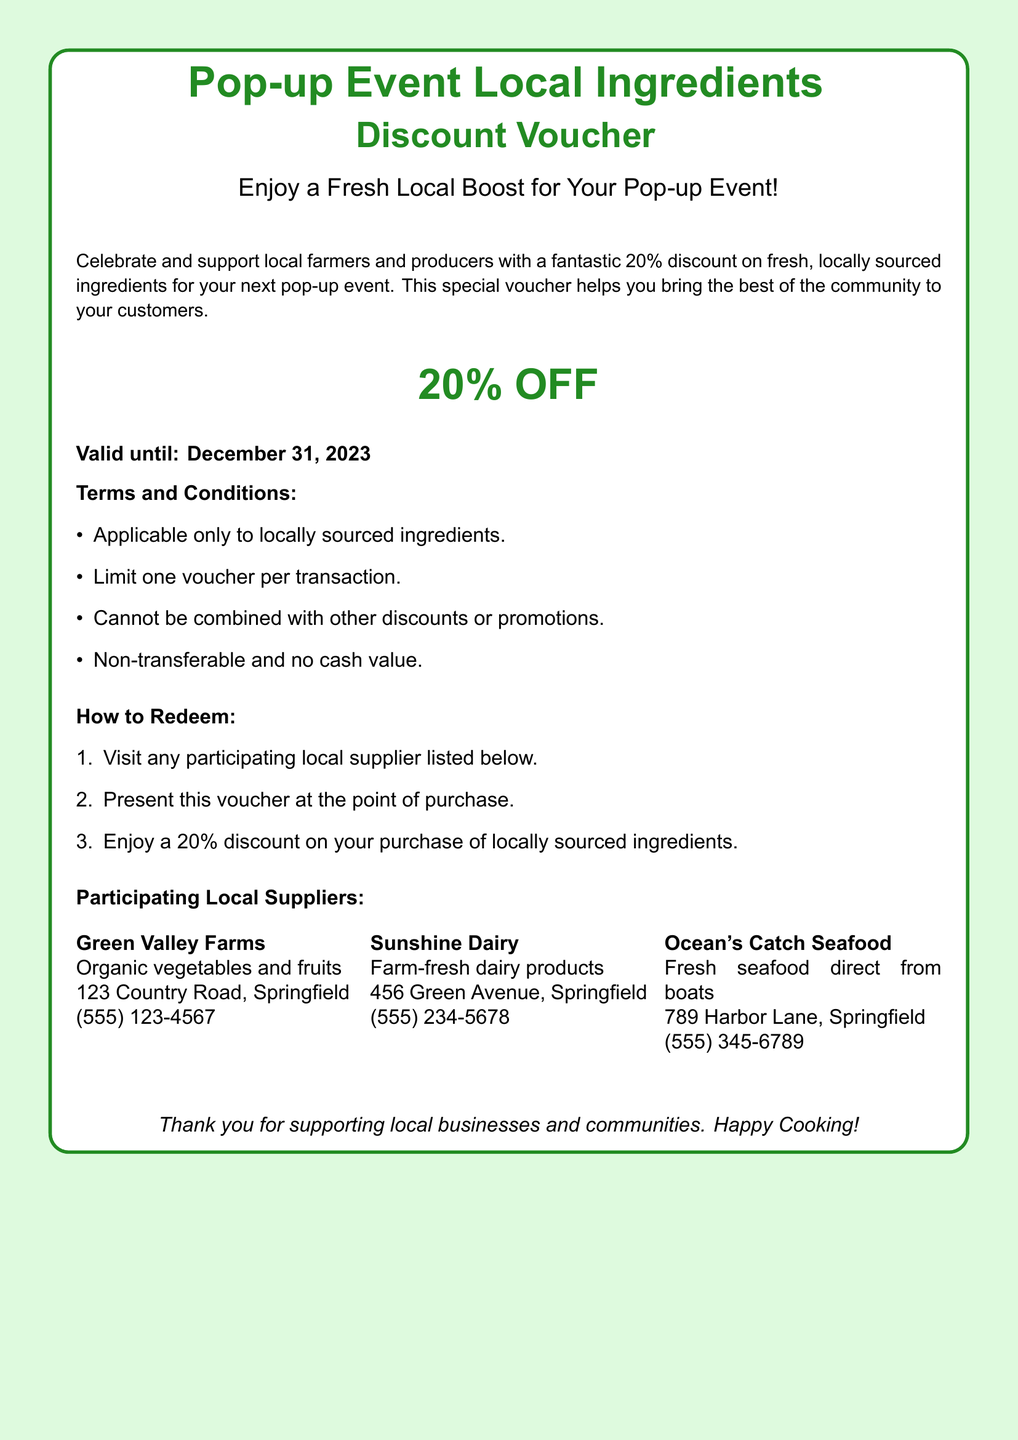What is the discount offered? The document states that the voucher provides a discount on fresh, locally sourced ingredients, specifically mentioning a 20% discount.
Answer: 20% What is the validity period of the voucher? The document specifies that the voucher is valid until December 31, 2023, indicating the time frame during which it can be used.
Answer: December 31, 2023 Which local supplier offers organic vegetables? The document lists Green Valley Farms as a local supplier that provides organic vegetables and fruits, answering the query about the type of food they sell.
Answer: Green Valley Farms How many suppliers are listed in the document? Counting the participating local suppliers presented in the document shows that there are three suppliers mentioned.
Answer: 3 What is the condition related to combining discounts? The document states that the voucher cannot be combined with other discounts or promotions, addressing limitations on usage.
Answer: Cannot be combined What is required to redeem the voucher? The redeeming process involves presenting the voucher at the point of purchase, which is specifically outlined in the document on how to utilize the discount.
Answer: Present this voucher What kind of products does Sunshine Dairy provide? According to the document, Sunshine Dairy supplies farm-fresh dairy products, identifying the category of products this supplier offers.
Answer: Dairy products Is the voucher transferable? The terms state that the voucher is non-transferable, indicating that it cannot be given to another person.
Answer: Non-transferable What is the purpose of this voucher? The document emphasizes that the voucher aims to support local farmers and producers by encouraging the purchase of fresh, locally sourced ingredients.
Answer: Support local farmers 